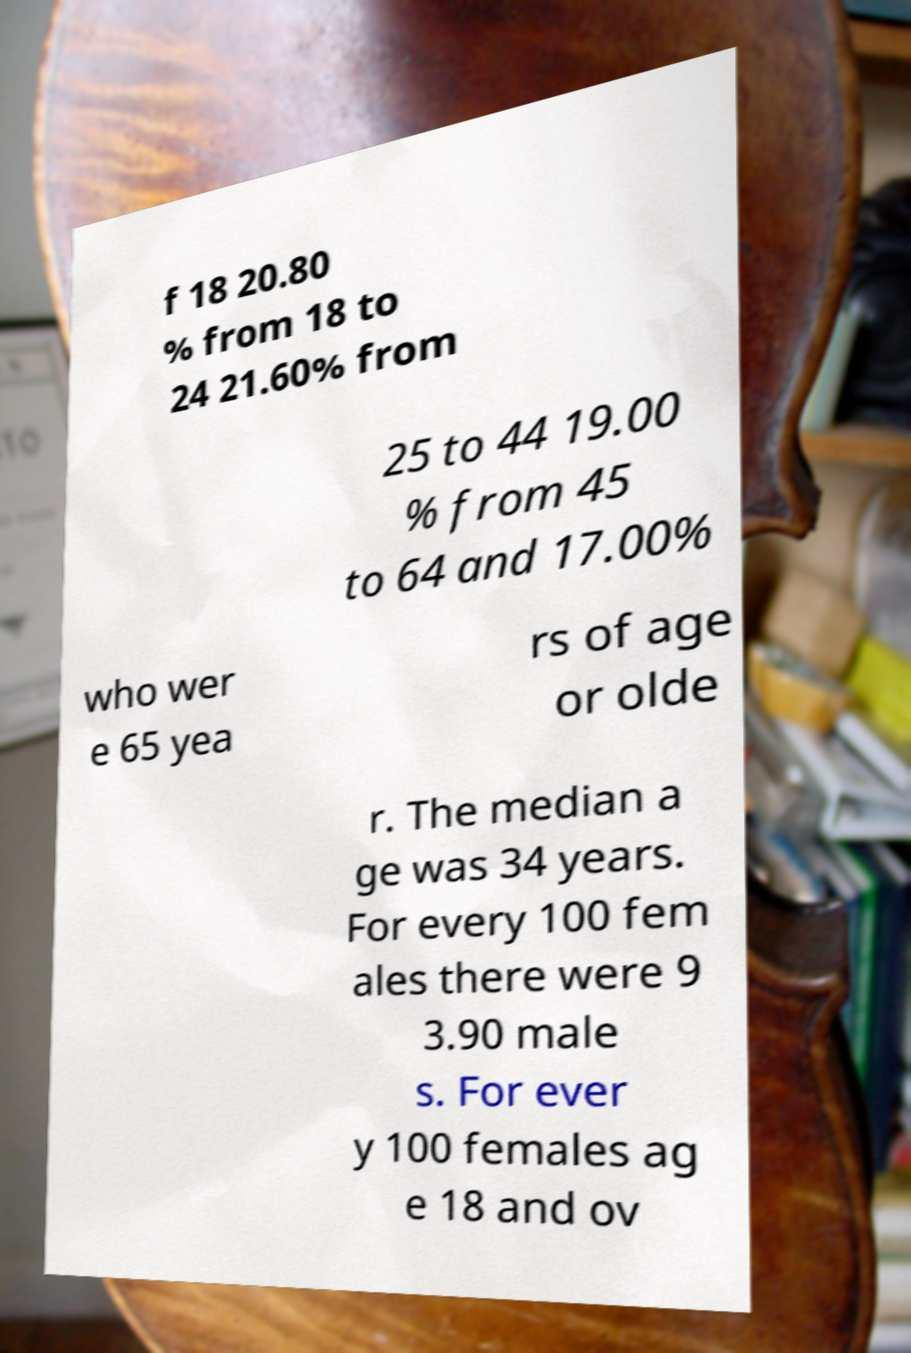What messages or text are displayed in this image? I need them in a readable, typed format. f 18 20.80 % from 18 to 24 21.60% from 25 to 44 19.00 % from 45 to 64 and 17.00% who wer e 65 yea rs of age or olde r. The median a ge was 34 years. For every 100 fem ales there were 9 3.90 male s. For ever y 100 females ag e 18 and ov 